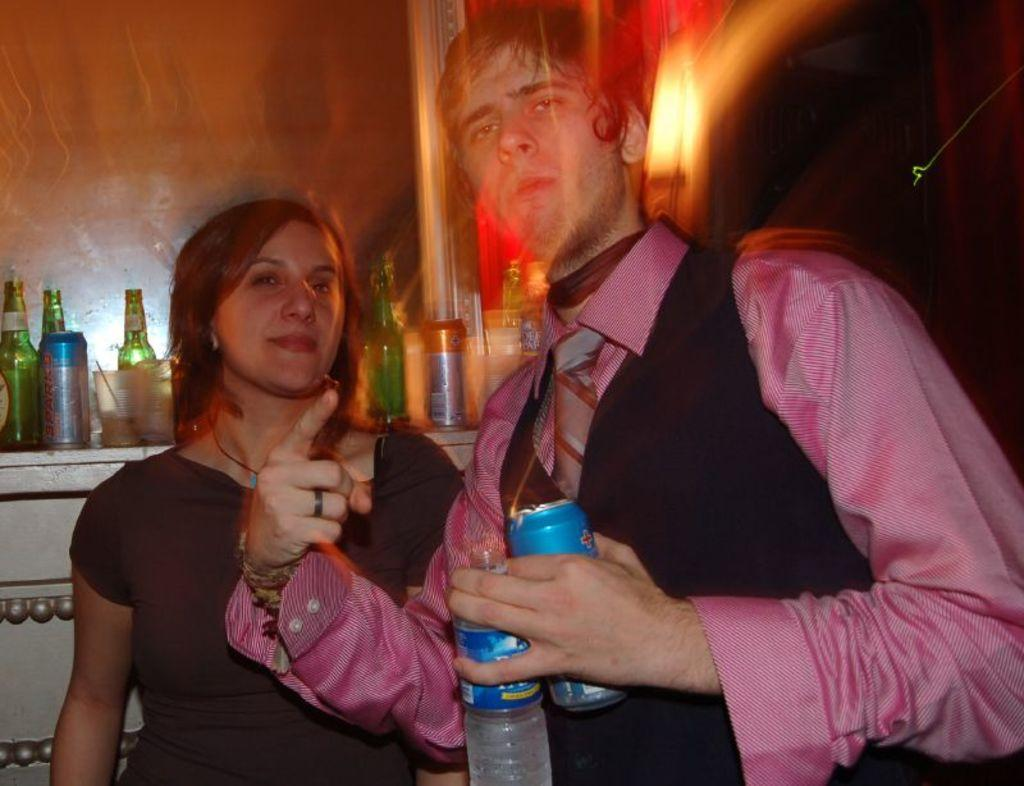Who is on the right side of the image? There is a man standing on the right side of the image. What is the man holding in his hands? The man is holding two bottles in his hands. Who is on the left side of the image? There is a woman standing on the left side of the image. How is the woman positioned in relation to the man? The woman is standing behind the man. How many bottles can be seen in the image? There are bottles present in the image, and the man is holding two of them. What type of pain is the man experiencing in the image? There is no indication in the image that the man is experiencing any pain. Can you tell me how many flies are present in the image? There are no flies visible in the image. 